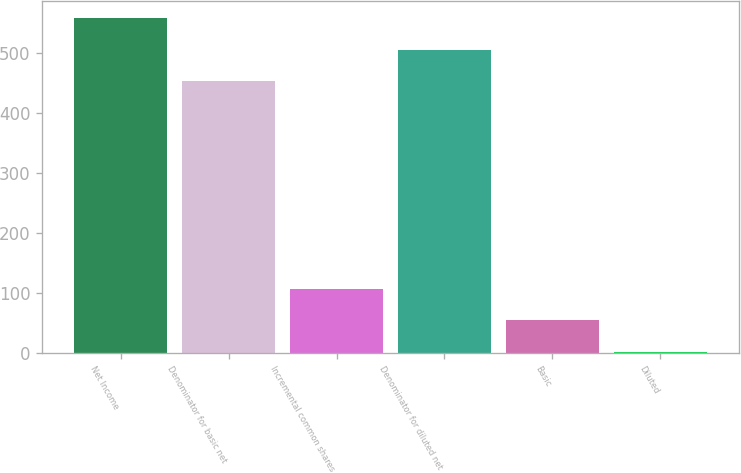Convert chart to OTSL. <chart><loc_0><loc_0><loc_500><loc_500><bar_chart><fcel>Net Income<fcel>Denominator for basic net<fcel>Incremental common shares<fcel>Denominator for diluted net<fcel>Basic<fcel>Diluted<nl><fcel>557.58<fcel>452<fcel>106.64<fcel>504.79<fcel>53.85<fcel>1.06<nl></chart> 